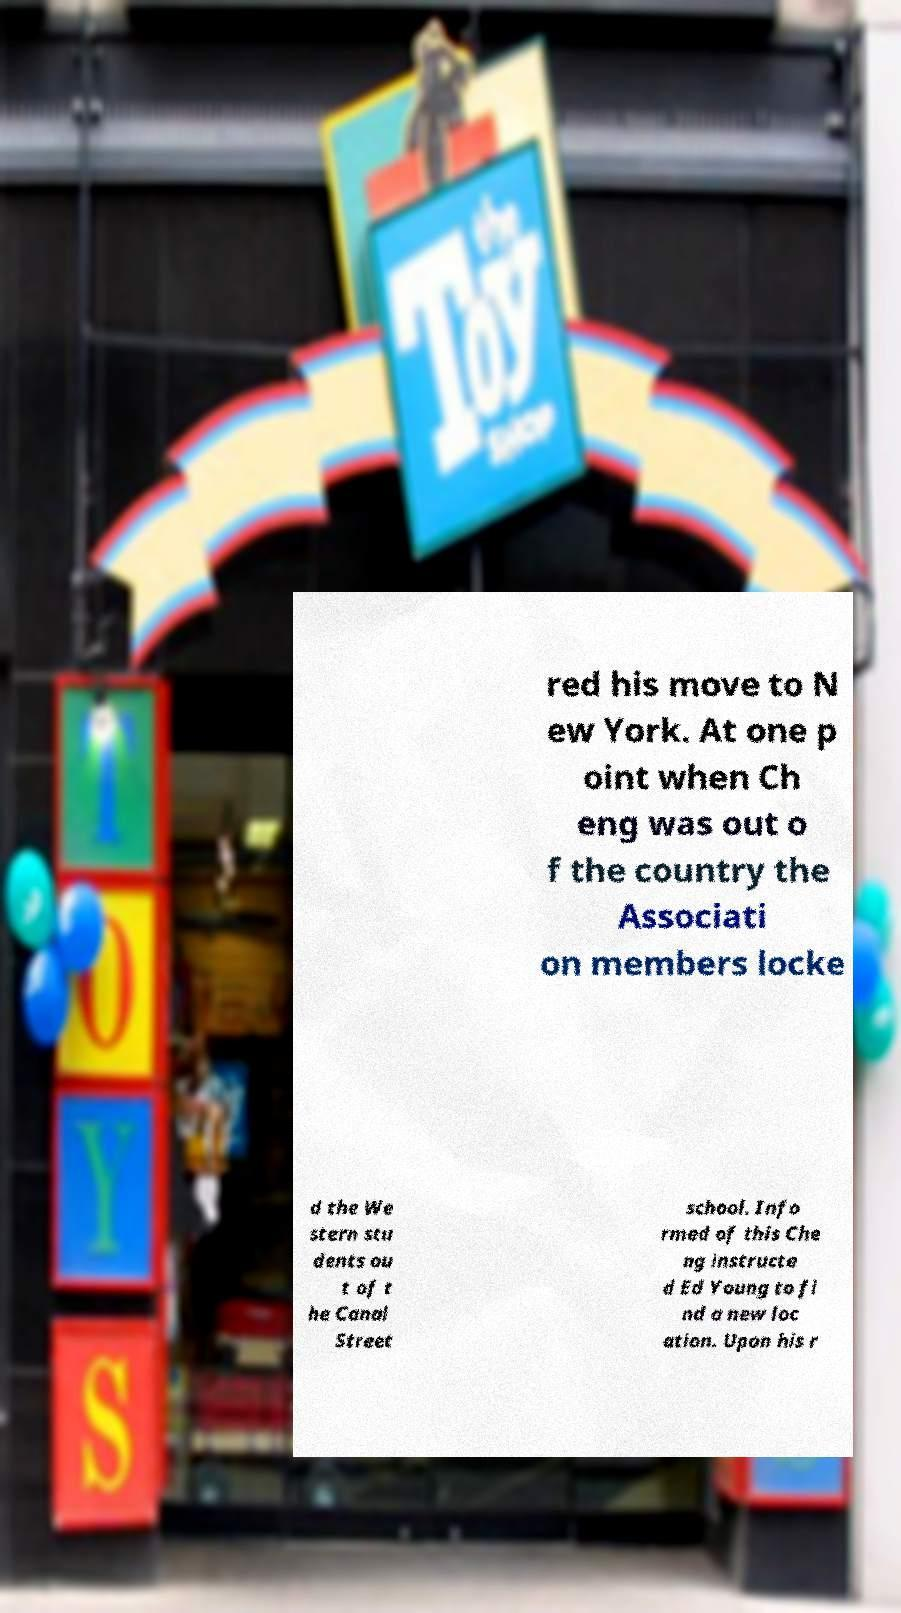Can you read and provide the text displayed in the image?This photo seems to have some interesting text. Can you extract and type it out for me? red his move to N ew York. At one p oint when Ch eng was out o f the country the Associati on members locke d the We stern stu dents ou t of t he Canal Street school. Info rmed of this Che ng instructe d Ed Young to fi nd a new loc ation. Upon his r 